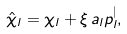Convert formula to latex. <formula><loc_0><loc_0><loc_500><loc_500>\hat { \chi } _ { l } = \chi _ { l } + \xi \, a _ { l } p _ { l } ^ { | } ,</formula> 